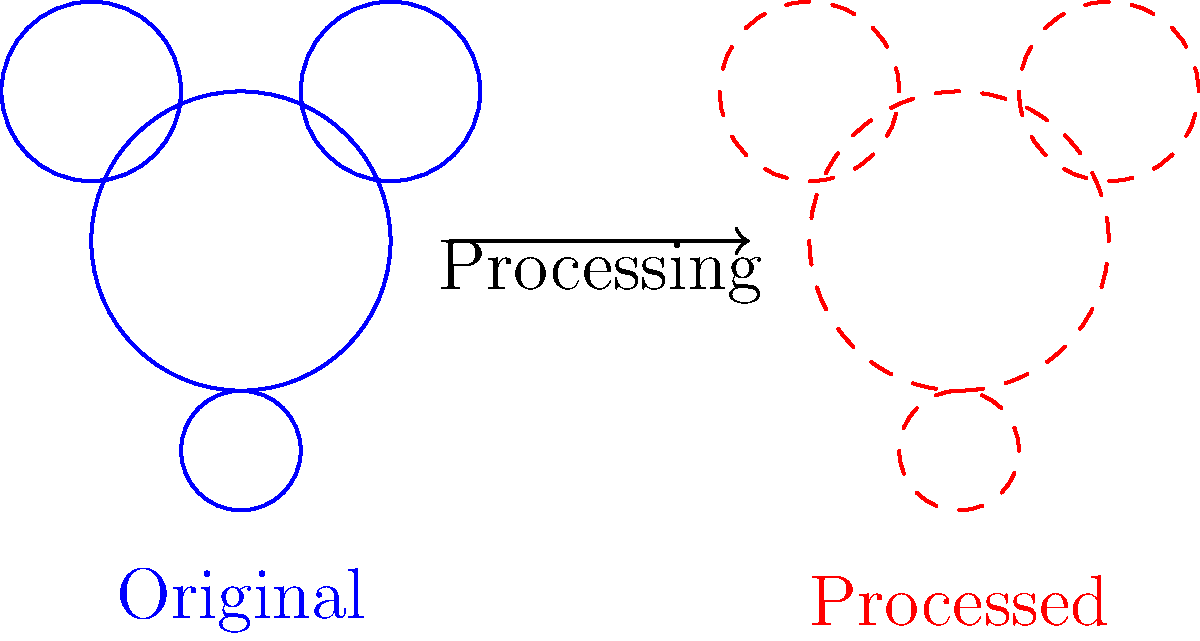Given an image processing task using SciPy's ndimage module, which of the following operations would result in the transformation shown in the figure, where the processed image (right) appears to have smoother edges compared to the original image (left)?

A) Gaussian filter
B) Sobel filter
C) Median filter
D) Laplace filter To determine the correct operation that results in the transformation shown in the figure, let's analyze the characteristics of each filter:

1. Gaussian filter:
   - Applies a smoothing effect to the image
   - Reduces noise and detail
   - Blurs edges, making them appear smoother
   - Preserves the overall shape of objects

2. Sobel filter:
   - Emphasizes edges in the image
   - Increases contrast between edges and non-edges
   - Would make edges appear sharper, not smoother

3. Median filter:
   - Reduces noise while preserving edges
   - Effective for removing salt-and-pepper noise
   - Typically doesn't smooth edges as much as Gaussian filter

4. Laplace filter:
   - Enhances edges and fine details
   - Increases contrast in edge regions
   - Would make edges appear sharper and more pronounced, not smoother

Analyzing the figure, we can observe that:
- The processed image has smoother, less defined edges compared to the original
- The overall shape and size of the objects are preserved
- There's a general blurring effect applied to the entire image

Given these observations, the Gaussian filter (option A) is the most likely operation to produce the shown transformation. The Gaussian filter is known for its smoothing effect, which reduces noise and detail while preserving the overall structure of the image. This perfectly matches the observed changes in the figure.

To implement this in SciPy's ndimage module, you would use:

```python
from scipy import ndimage
import numpy as np

# Assuming 'image' is your input image
sigma = 1.0  # Adjust this value to control the amount of smoothing
smoothed_image = ndimage.gaussian_filter(image, sigma=sigma)
```

The `sigma` parameter controls the strength of the smoothing effect. A larger value of `sigma` would result in more pronounced smoothing.
Answer: A) Gaussian filter 